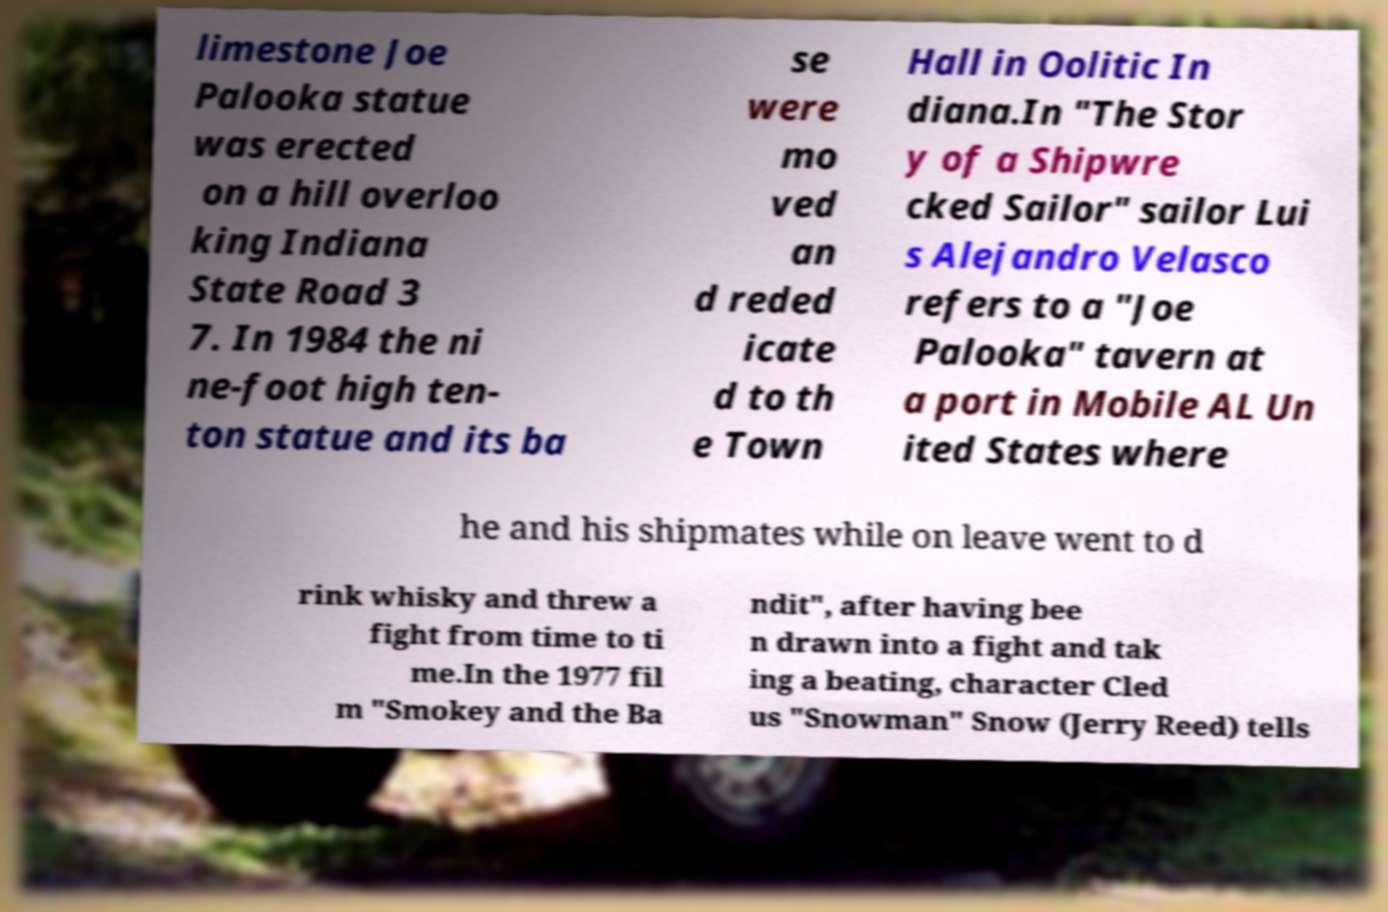Could you assist in decoding the text presented in this image and type it out clearly? limestone Joe Palooka statue was erected on a hill overloo king Indiana State Road 3 7. In 1984 the ni ne-foot high ten- ton statue and its ba se were mo ved an d reded icate d to th e Town Hall in Oolitic In diana.In "The Stor y of a Shipwre cked Sailor" sailor Lui s Alejandro Velasco refers to a "Joe Palooka" tavern at a port in Mobile AL Un ited States where he and his shipmates while on leave went to d rink whisky and threw a fight from time to ti me.In the 1977 fil m "Smokey and the Ba ndit", after having bee n drawn into a fight and tak ing a beating, character Cled us "Snowman" Snow (Jerry Reed) tells 